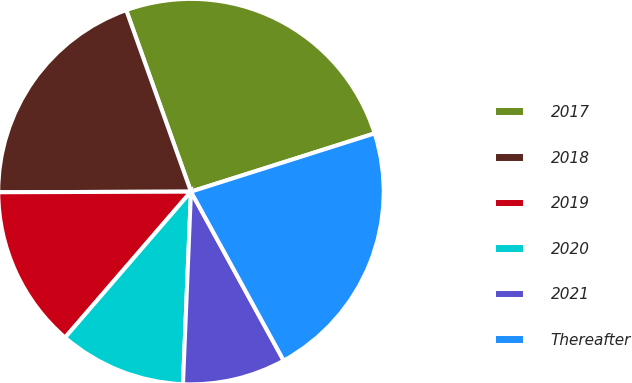<chart> <loc_0><loc_0><loc_500><loc_500><pie_chart><fcel>2017<fcel>2018<fcel>2019<fcel>2020<fcel>2021<fcel>Thereafter<nl><fcel>25.57%<fcel>19.6%<fcel>13.62%<fcel>10.67%<fcel>8.65%<fcel>21.9%<nl></chart> 